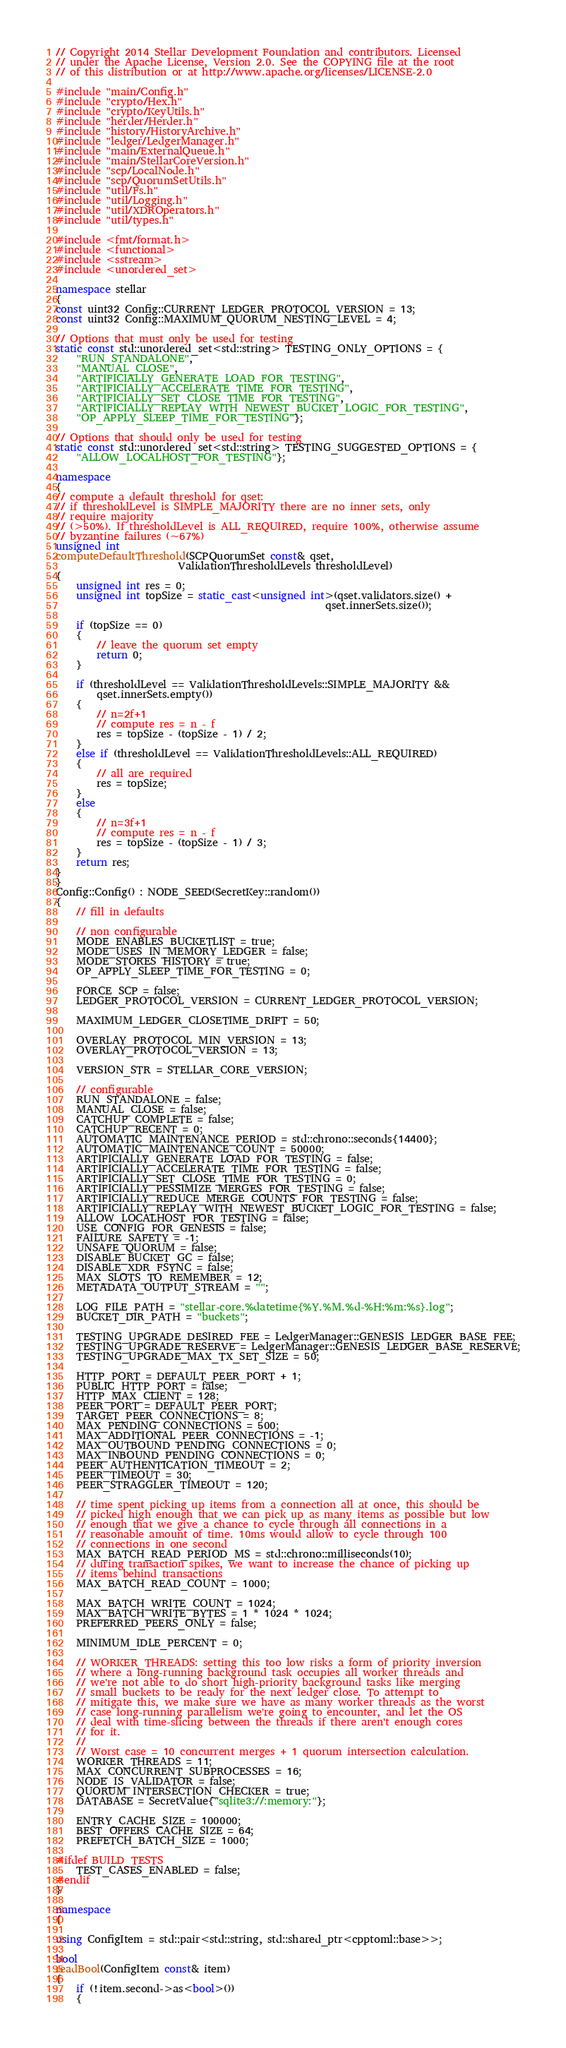<code> <loc_0><loc_0><loc_500><loc_500><_C++_>
// Copyright 2014 Stellar Development Foundation and contributors. Licensed
// under the Apache License, Version 2.0. See the COPYING file at the root
// of this distribution or at http://www.apache.org/licenses/LICENSE-2.0

#include "main/Config.h"
#include "crypto/Hex.h"
#include "crypto/KeyUtils.h"
#include "herder/Herder.h"
#include "history/HistoryArchive.h"
#include "ledger/LedgerManager.h"
#include "main/ExternalQueue.h"
#include "main/StellarCoreVersion.h"
#include "scp/LocalNode.h"
#include "scp/QuorumSetUtils.h"
#include "util/Fs.h"
#include "util/Logging.h"
#include "util/XDROperators.h"
#include "util/types.h"

#include <fmt/format.h>
#include <functional>
#include <sstream>
#include <unordered_set>

namespace stellar
{
const uint32 Config::CURRENT_LEDGER_PROTOCOL_VERSION = 13;
const uint32 Config::MAXIMUM_QUORUM_NESTING_LEVEL = 4;

// Options that must only be used for testing
static const std::unordered_set<std::string> TESTING_ONLY_OPTIONS = {
    "RUN_STANDALONE",
    "MANUAL_CLOSE",
    "ARTIFICIALLY_GENERATE_LOAD_FOR_TESTING",
    "ARTIFICIALLY_ACCELERATE_TIME_FOR_TESTING",
    "ARTIFICIALLY_SET_CLOSE_TIME_FOR_TESTING",
    "ARTIFICIALLY_REPLAY_WITH_NEWEST_BUCKET_LOGIC_FOR_TESTING",
    "OP_APPLY_SLEEP_TIME_FOR_TESTING"};

// Options that should only be used for testing
static const std::unordered_set<std::string> TESTING_SUGGESTED_OPTIONS = {
    "ALLOW_LOCALHOST_FOR_TESTING"};

namespace
{
// compute a default threshold for qset:
// if thresholdLevel is SIMPLE_MAJORITY there are no inner sets, only
// require majority
// (>50%). If thresholdLevel is ALL_REQUIRED, require 100%, otherwise assume
// byzantine failures (~67%)
unsigned int
computeDefaultThreshold(SCPQuorumSet const& qset,
                        ValidationThresholdLevels thresholdLevel)
{
    unsigned int res = 0;
    unsigned int topSize = static_cast<unsigned int>(qset.validators.size() +
                                                     qset.innerSets.size());

    if (topSize == 0)
    {
        // leave the quorum set empty
        return 0;
    }

    if (thresholdLevel == ValidationThresholdLevels::SIMPLE_MAJORITY &&
        qset.innerSets.empty())
    {
        // n=2f+1
        // compute res = n - f
        res = topSize - (topSize - 1) / 2;
    }
    else if (thresholdLevel == ValidationThresholdLevels::ALL_REQUIRED)
    {
        // all are required
        res = topSize;
    }
    else
    {
        // n=3f+1
        // compute res = n - f
        res = topSize - (topSize - 1) / 3;
    }
    return res;
}
}
Config::Config() : NODE_SEED(SecretKey::random())
{
    // fill in defaults

    // non configurable
    MODE_ENABLES_BUCKETLIST = true;
    MODE_USES_IN_MEMORY_LEDGER = false;
    MODE_STORES_HISTORY = true;
    OP_APPLY_SLEEP_TIME_FOR_TESTING = 0;

    FORCE_SCP = false;
    LEDGER_PROTOCOL_VERSION = CURRENT_LEDGER_PROTOCOL_VERSION;

    MAXIMUM_LEDGER_CLOSETIME_DRIFT = 50;

    OVERLAY_PROTOCOL_MIN_VERSION = 13;
    OVERLAY_PROTOCOL_VERSION = 13;

    VERSION_STR = STELLAR_CORE_VERSION;

    // configurable
    RUN_STANDALONE = false;
    MANUAL_CLOSE = false;
    CATCHUP_COMPLETE = false;
    CATCHUP_RECENT = 0;
    AUTOMATIC_MAINTENANCE_PERIOD = std::chrono::seconds{14400};
    AUTOMATIC_MAINTENANCE_COUNT = 50000;
    ARTIFICIALLY_GENERATE_LOAD_FOR_TESTING = false;
    ARTIFICIALLY_ACCELERATE_TIME_FOR_TESTING = false;
    ARTIFICIALLY_SET_CLOSE_TIME_FOR_TESTING = 0;
    ARTIFICIALLY_PESSIMIZE_MERGES_FOR_TESTING = false;
    ARTIFICIALLY_REDUCE_MERGE_COUNTS_FOR_TESTING = false;
    ARTIFICIALLY_REPLAY_WITH_NEWEST_BUCKET_LOGIC_FOR_TESTING = false;
    ALLOW_LOCALHOST_FOR_TESTING = false;
    USE_CONFIG_FOR_GENESIS = false;
    FAILURE_SAFETY = -1;
    UNSAFE_QUORUM = false;
    DISABLE_BUCKET_GC = false;
    DISABLE_XDR_FSYNC = false;
    MAX_SLOTS_TO_REMEMBER = 12;
    METADATA_OUTPUT_STREAM = "";

    LOG_FILE_PATH = "stellar-core.%datetime{%Y.%M.%d-%H:%m:%s}.log";
    BUCKET_DIR_PATH = "buckets";

    TESTING_UPGRADE_DESIRED_FEE = LedgerManager::GENESIS_LEDGER_BASE_FEE;
    TESTING_UPGRADE_RESERVE = LedgerManager::GENESIS_LEDGER_BASE_RESERVE;
    TESTING_UPGRADE_MAX_TX_SET_SIZE = 50;

    HTTP_PORT = DEFAULT_PEER_PORT + 1;
    PUBLIC_HTTP_PORT = false;
    HTTP_MAX_CLIENT = 128;
    PEER_PORT = DEFAULT_PEER_PORT;
    TARGET_PEER_CONNECTIONS = 8;
    MAX_PENDING_CONNECTIONS = 500;
    MAX_ADDITIONAL_PEER_CONNECTIONS = -1;
    MAX_OUTBOUND_PENDING_CONNECTIONS = 0;
    MAX_INBOUND_PENDING_CONNECTIONS = 0;
    PEER_AUTHENTICATION_TIMEOUT = 2;
    PEER_TIMEOUT = 30;
    PEER_STRAGGLER_TIMEOUT = 120;

    // time spent picking up items from a connection all at once, this should be
    // picked high enough that we can pick up as many items as possible but low
    // enough that we give a chance to cycle through all connections in a
    // reasonable amount of time. 10ms would allow to cycle through 100
    // connections in one second
    MAX_BATCH_READ_PERIOD_MS = std::chrono::milliseconds(10);
    // during transaction spikes, we want to increase the chance of picking up
    // items behind transactions
    MAX_BATCH_READ_COUNT = 1000;

    MAX_BATCH_WRITE_COUNT = 1024;
    MAX_BATCH_WRITE_BYTES = 1 * 1024 * 1024;
    PREFERRED_PEERS_ONLY = false;

    MINIMUM_IDLE_PERCENT = 0;

    // WORKER_THREADS: setting this too low risks a form of priority inversion
    // where a long-running background task occupies all worker threads and
    // we're not able to do short high-priority background tasks like merging
    // small buckets to be ready for the next ledger close. To attempt to
    // mitigate this, we make sure we have as many worker threads as the worst
    // case long-running parallelism we're going to encounter, and let the OS
    // deal with time-slicing between the threads if there aren't enough cores
    // for it.
    //
    // Worst case = 10 concurrent merges + 1 quorum intersection calculation.
    WORKER_THREADS = 11;
    MAX_CONCURRENT_SUBPROCESSES = 16;
    NODE_IS_VALIDATOR = false;
    QUORUM_INTERSECTION_CHECKER = true;
    DATABASE = SecretValue{"sqlite3://:memory:"};

    ENTRY_CACHE_SIZE = 100000;
    BEST_OFFERS_CACHE_SIZE = 64;
    PREFETCH_BATCH_SIZE = 1000;

#ifdef BUILD_TESTS
    TEST_CASES_ENABLED = false;
#endif
}

namespace
{

using ConfigItem = std::pair<std::string, std::shared_ptr<cpptoml::base>>;

bool
readBool(ConfigItem const& item)
{
    if (!item.second->as<bool>())
    {</code> 